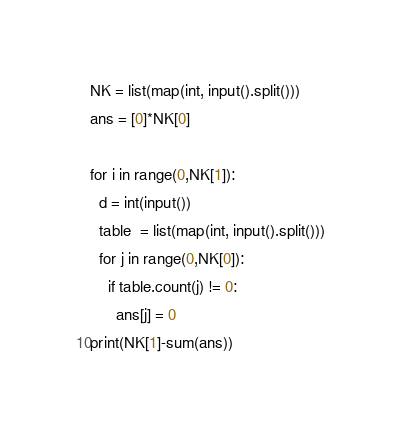<code> <loc_0><loc_0><loc_500><loc_500><_Python_>NK = list(map(int, input().split()))
ans = [0]*NK[0]

for i in range(0,NK[1]):
  d = int(input())
  table  = list(map(int, input().split()))
  for j in range(0,NK[0]):
    if table.count(j) != 0:
      ans[j] = 0
print(NK[1]-sum(ans))</code> 